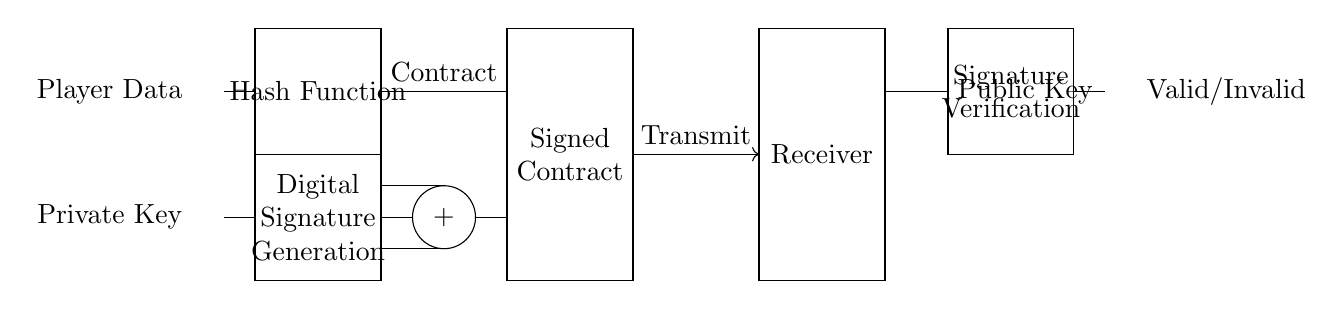What component is used to generate a digital signature? The component labeled "Digital Signature Generation" is responsible for creating the digital signature based on the player data and the private key.
Answer: Digital Signature Generation What connects the hash function to the digital signature generation? There is a direct connection where the output of the hash function feeds into the digital signature generation process, demonstrating how the hashed data is used to create the signature.
Answer: Direct connection What type of key is used for verifying the signature? The circuit diagram shows the use of a public key for the signature verification process, which allows the receiver to confirm authenticity.
Answer: Public Key How many main components are involved in the signature verification process? In the signature verification process, the diagram shows three main components: the signed contract, the public key, and the signature verification block, indicating a clear flow of information.
Answer: Three What happens if the signature verification fails? The output indicated in the diagram states "Invalid," which implies that if the verification process does not match the expected results, the contract signature is not valid.
Answer: Invalid What role does the private key play in this system? The private key is shown as a fundamental input to the digital signature generation, highlighting its importance in securely creating the unique digital signature that represents the player data.
Answer: Securely creating digital signature What is added to the contract during the signing process? The circuit indicates that a digital signature is added to the contract, forming a signed contract that encapsulates both the original contract and the verification data necessary for later validation.
Answer: Digital signature 